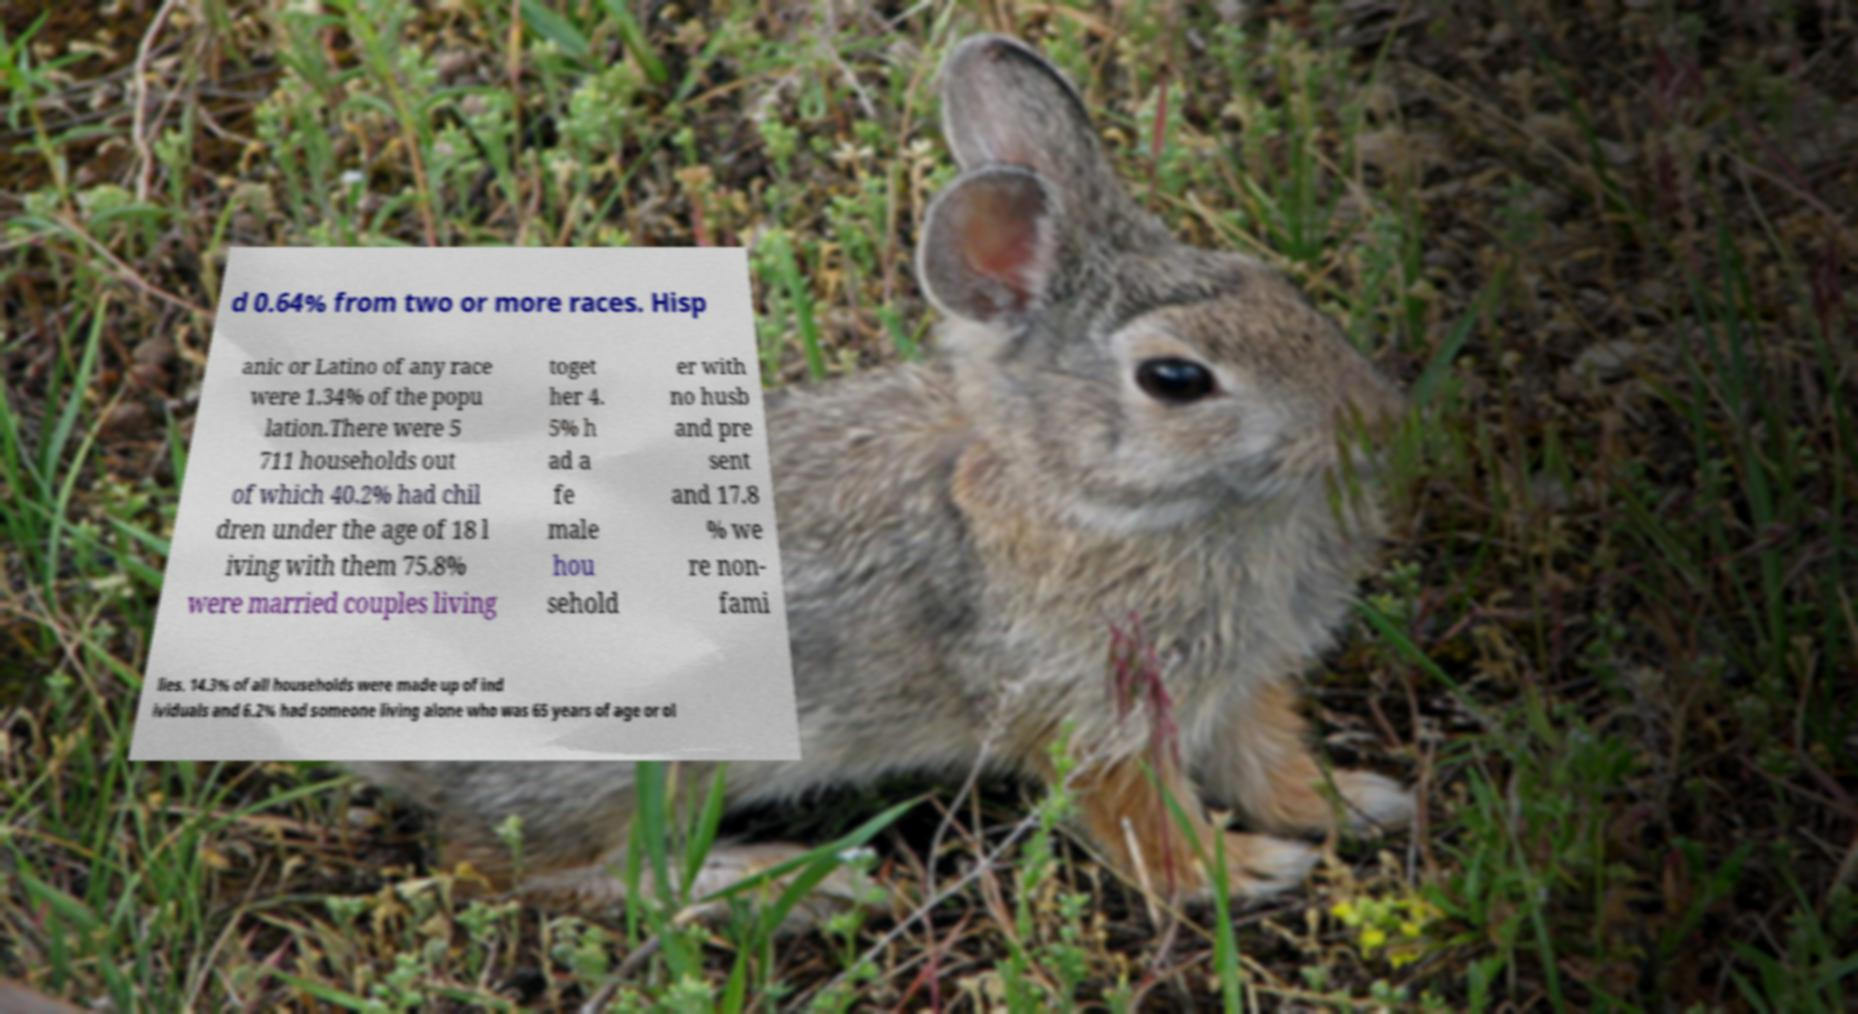I need the written content from this picture converted into text. Can you do that? d 0.64% from two or more races. Hisp anic or Latino of any race were 1.34% of the popu lation.There were 5 711 households out of which 40.2% had chil dren under the age of 18 l iving with them 75.8% were married couples living toget her 4. 5% h ad a fe male hou sehold er with no husb and pre sent and 17.8 % we re non- fami lies. 14.3% of all households were made up of ind ividuals and 6.2% had someone living alone who was 65 years of age or ol 